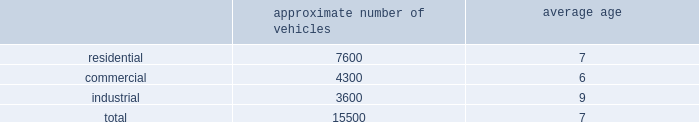Fleet automation approximately 66% ( 66 % ) of our residential routes have been converted to automated single driver trucks .
By converting our residential routes to automated service , we reduce labor costs , improve driver productivity and create a safer work environment for our employees .
Additionally , communities using automated vehicles have higher participation rates in recycling programs , thereby complementing our initiative to expand our recycling capabilities .
Fleet conversion to compressed natural gas ( cng ) approximately 12% ( 12 % ) of our fleet operates on natural gas .
We expect to continue our gradual fleet conversion to cng , our preferred alternative fuel technology , as part of our ordinary annual fleet replacement process .
We believe a gradual fleet conversion is most prudent to realize the full value of our previous fleet investments .
Approximately 50% ( 50 % ) of our replacement vehicle purchases during 2013 were cng vehicles .
We believe using cng vehicles provides us a competitive advantage in communities with strict clean emission objectives or initiatives that focus on protecting the environment .
Although upfront costs are higher , we expect that using natural gas will reduce our overall fleet operating costs through lower fuel expenses .
Standardized maintenance based on an industry trade publication , we operate the eighth largest vocational fleet in the united states .
As of december 31 , 2013 , our average fleet age in years , by line of business , was as follows : approximate number of vehicles average age .
Through standardization of core functions , we believe we can minimize variability in our maintenance processes resulting in higher vehicle quality while extending the service life of our fleet .
We believe operating a more reliable , safer and efficient fleet will lower our operating costs .
We have completed implementation of standardized maintenance programs for approximately 45% ( 45 % ) of our fleet maintenance operations as of december 31 , 2013 .
Cash utilization strategy key components of our cash utilization strategy include increasing free cash flow and improving our return on invested capital .
Our definition of free cash flow , which is not a measure determined in accordance with united states generally accepted accounting principles ( u.s .
Gaap ) , is cash provided by operating activities less purchases of property and equipment , plus proceeds from sales of property and equipment as presented in our consolidated statements of cash flows .
For a discussion and reconciliation of free cash flow , you should read the 201cfree cash flow 201d section of our management 2019s discussion and analysis of financial condition and results of operations contained in item 7 of this form 10-k .
We believe free cash flow drives shareholder value and provides useful information regarding the recurring cash provided by our operations .
Free cash flow also demonstrates our ability to execute our cash utilization strategy , which includes investments in acquisitions and returning a majority of free cash flow to our shareholders through dividends and share repurchases .
We are committed to an efficient capital structure and maintaining our investment grade rating .
We manage our free cash flow by ensuring that capital expenditures and operating asset levels are appropriate in light of our existing business and growth opportunities , as well as by closely managing our working capital , which consists primarily of accounts receivable , accounts payable , and accrued landfill and environmental costs. .
What is the approximate number of vehicle in the fleet that are operating on compressed natural gas ( cng ) approximately 12% ( 12 % )? 
Rationale: to obtain the number multiply the amount by the percent
Computations: (15500 * 12%)
Answer: 1860.0. 